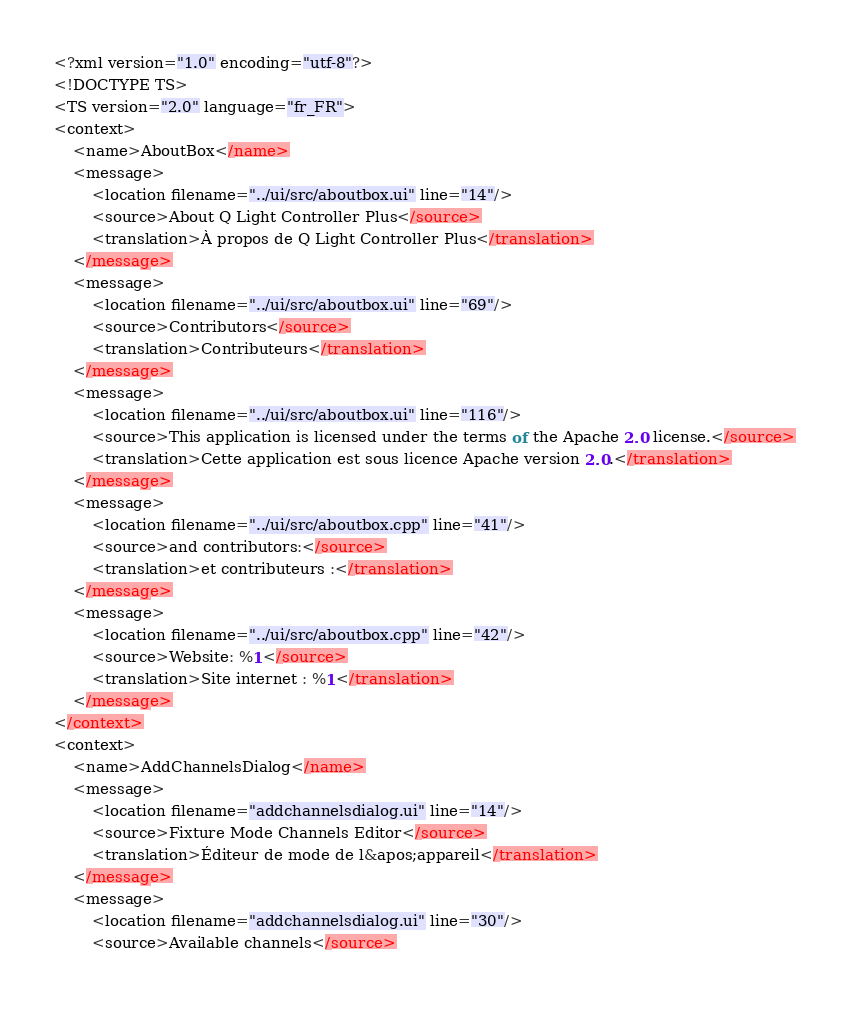Convert code to text. <code><loc_0><loc_0><loc_500><loc_500><_TypeScript_><?xml version="1.0" encoding="utf-8"?>
<!DOCTYPE TS>
<TS version="2.0" language="fr_FR">
<context>
    <name>AboutBox</name>
    <message>
        <location filename="../ui/src/aboutbox.ui" line="14"/>
        <source>About Q Light Controller Plus</source>
        <translation>À propos de Q Light Controller Plus</translation>
    </message>
    <message>
        <location filename="../ui/src/aboutbox.ui" line="69"/>
        <source>Contributors</source>
        <translation>Contributeurs</translation>
    </message>
    <message>
        <location filename="../ui/src/aboutbox.ui" line="116"/>
        <source>This application is licensed under the terms of the Apache 2.0 license.</source>
        <translation>Cette application est sous licence Apache version 2.0.</translation>
    </message>
    <message>
        <location filename="../ui/src/aboutbox.cpp" line="41"/>
        <source>and contributors:</source>
        <translation>et contributeurs :</translation>
    </message>
    <message>
        <location filename="../ui/src/aboutbox.cpp" line="42"/>
        <source>Website: %1</source>
        <translation>Site internet : %1</translation>
    </message>
</context>
<context>
    <name>AddChannelsDialog</name>
    <message>
        <location filename="addchannelsdialog.ui" line="14"/>
        <source>Fixture Mode Channels Editor</source>
        <translation>Éditeur de mode de l&apos;appareil</translation>
    </message>
    <message>
        <location filename="addchannelsdialog.ui" line="30"/>
        <source>Available channels</source></code> 